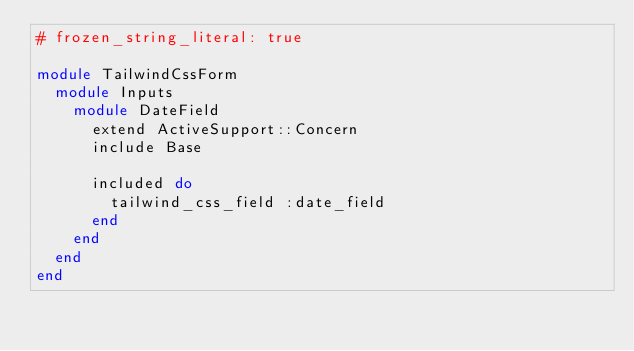<code> <loc_0><loc_0><loc_500><loc_500><_Ruby_># frozen_string_literal: true

module TailwindCssForm
  module Inputs
    module DateField
      extend ActiveSupport::Concern
      include Base

      included do
        tailwind_css_field :date_field
      end
    end
  end
end
</code> 